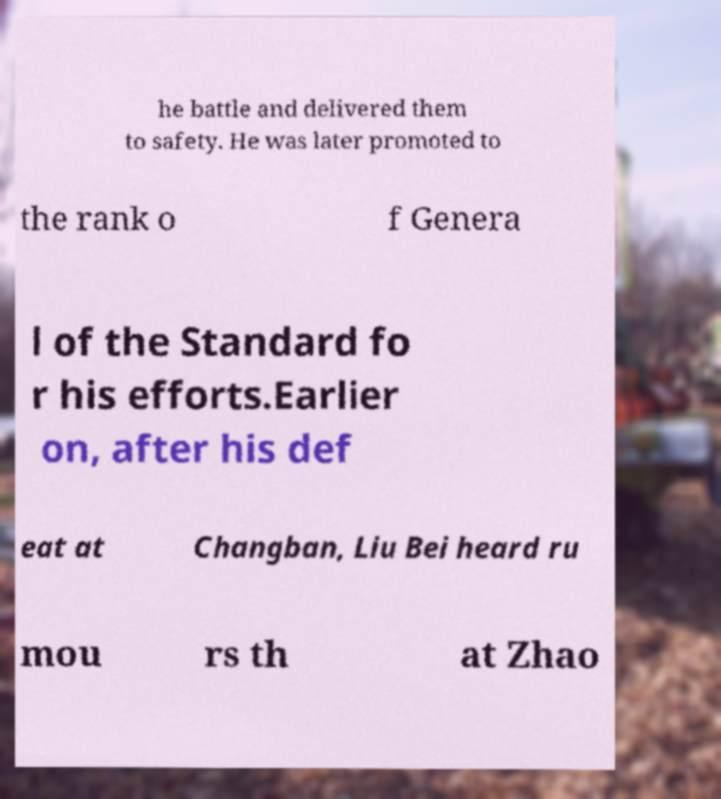Could you extract and type out the text from this image? he battle and delivered them to safety. He was later promoted to the rank o f Genera l of the Standard fo r his efforts.Earlier on, after his def eat at Changban, Liu Bei heard ru mou rs th at Zhao 